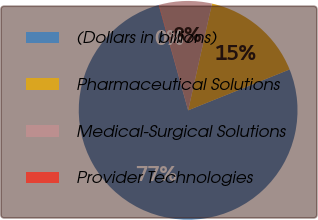Convert chart. <chart><loc_0><loc_0><loc_500><loc_500><pie_chart><fcel>(Dollars in billions)<fcel>Pharmaceutical Solutions<fcel>Medical-Surgical Solutions<fcel>Provider Technologies<nl><fcel>76.76%<fcel>15.41%<fcel>7.75%<fcel>0.08%<nl></chart> 